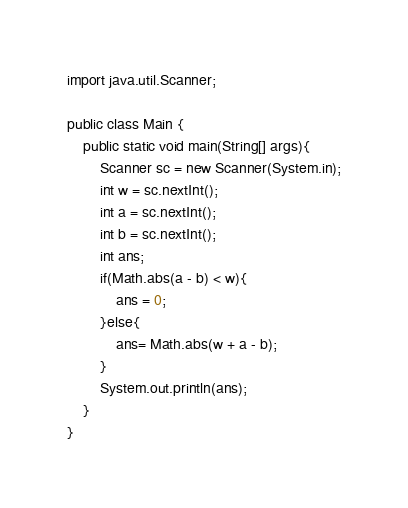Convert code to text. <code><loc_0><loc_0><loc_500><loc_500><_Java_>import java.util.Scanner;

public class Main {
	public static void main(String[] args){
		Scanner sc = new Scanner(System.in);
		int w = sc.nextInt();
		int a = sc.nextInt();
		int b = sc.nextInt();
		int ans;
		if(Math.abs(a - b) < w){
			ans = 0;
		}else{
			ans= Math.abs(w + a - b);
		}
		System.out.println(ans);
	}
}</code> 